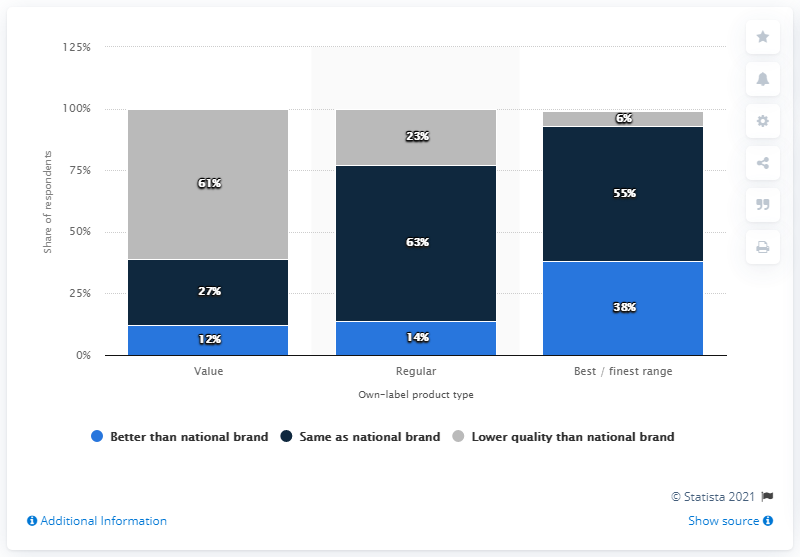Indicate a few pertinent items in this graphic. The average of the blue bar is approximately 21.33. The highest value of the dark blue bar in the chart is 63. 